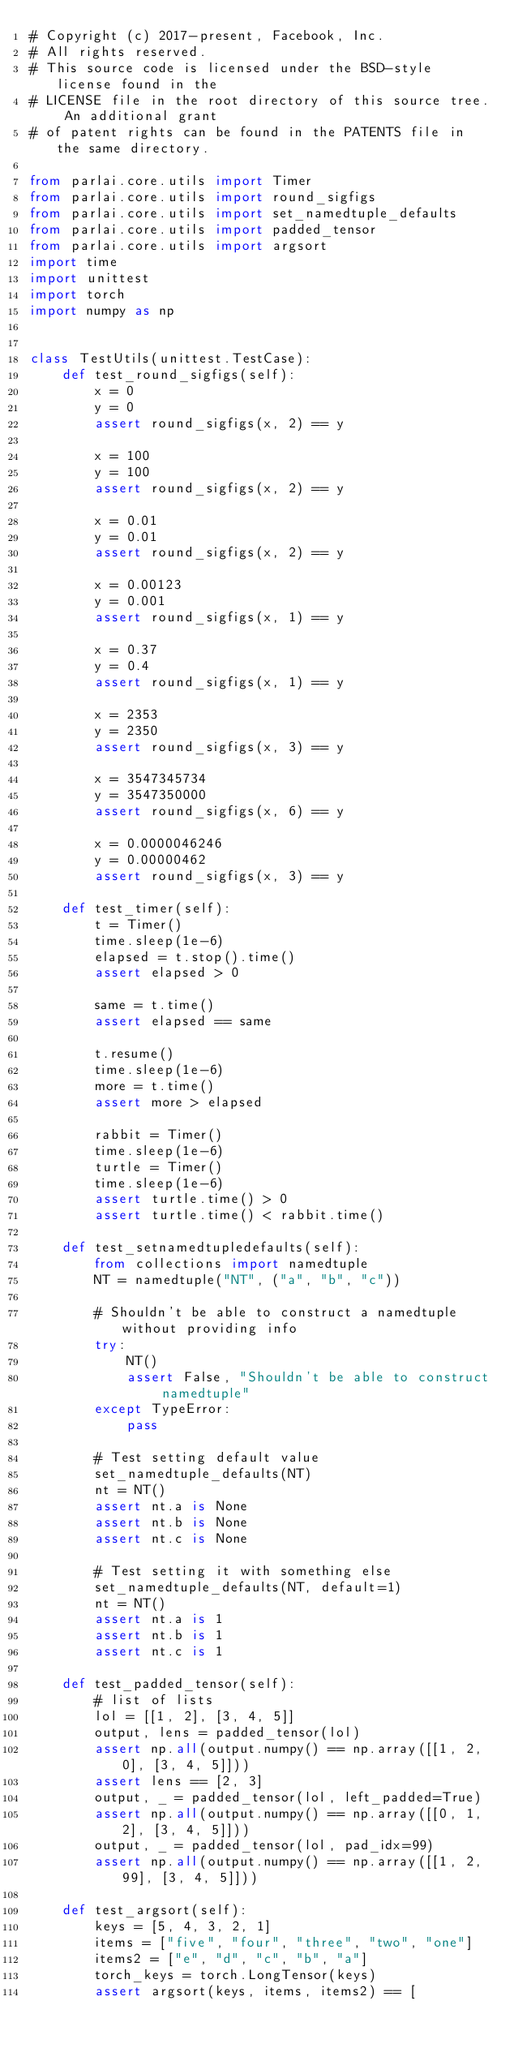Convert code to text. <code><loc_0><loc_0><loc_500><loc_500><_Python_># Copyright (c) 2017-present, Facebook, Inc.
# All rights reserved.
# This source code is licensed under the BSD-style license found in the
# LICENSE file in the root directory of this source tree. An additional grant
# of patent rights can be found in the PATENTS file in the same directory.

from parlai.core.utils import Timer
from parlai.core.utils import round_sigfigs
from parlai.core.utils import set_namedtuple_defaults
from parlai.core.utils import padded_tensor
from parlai.core.utils import argsort
import time
import unittest
import torch
import numpy as np


class TestUtils(unittest.TestCase):
    def test_round_sigfigs(self):
        x = 0
        y = 0
        assert round_sigfigs(x, 2) == y

        x = 100
        y = 100
        assert round_sigfigs(x, 2) == y

        x = 0.01
        y = 0.01
        assert round_sigfigs(x, 2) == y

        x = 0.00123
        y = 0.001
        assert round_sigfigs(x, 1) == y

        x = 0.37
        y = 0.4
        assert round_sigfigs(x, 1) == y

        x = 2353
        y = 2350
        assert round_sigfigs(x, 3) == y

        x = 3547345734
        y = 3547350000
        assert round_sigfigs(x, 6) == y

        x = 0.0000046246
        y = 0.00000462
        assert round_sigfigs(x, 3) == y

    def test_timer(self):
        t = Timer()
        time.sleep(1e-6)
        elapsed = t.stop().time()
        assert elapsed > 0

        same = t.time()
        assert elapsed == same

        t.resume()
        time.sleep(1e-6)
        more = t.time()
        assert more > elapsed

        rabbit = Timer()
        time.sleep(1e-6)
        turtle = Timer()
        time.sleep(1e-6)
        assert turtle.time() > 0
        assert turtle.time() < rabbit.time()

    def test_setnamedtupledefaults(self):
        from collections import namedtuple
        NT = namedtuple("NT", ("a", "b", "c"))

        # Shouldn't be able to construct a namedtuple without providing info
        try:
            NT()
            assert False, "Shouldn't be able to construct namedtuple"
        except TypeError:
            pass

        # Test setting default value
        set_namedtuple_defaults(NT)
        nt = NT()
        assert nt.a is None
        assert nt.b is None
        assert nt.c is None

        # Test setting it with something else
        set_namedtuple_defaults(NT, default=1)
        nt = NT()
        assert nt.a is 1
        assert nt.b is 1
        assert nt.c is 1

    def test_padded_tensor(self):
        # list of lists
        lol = [[1, 2], [3, 4, 5]]
        output, lens = padded_tensor(lol)
        assert np.all(output.numpy() == np.array([[1, 2, 0], [3, 4, 5]]))
        assert lens == [2, 3]
        output, _ = padded_tensor(lol, left_padded=True)
        assert np.all(output.numpy() == np.array([[0, 1, 2], [3, 4, 5]]))
        output, _ = padded_tensor(lol, pad_idx=99)
        assert np.all(output.numpy() == np.array([[1, 2, 99], [3, 4, 5]]))

    def test_argsort(self):
        keys = [5, 4, 3, 2, 1]
        items = ["five", "four", "three", "two", "one"]
        items2 = ["e", "d", "c", "b", "a"]
        torch_keys = torch.LongTensor(keys)
        assert argsort(keys, items, items2) == [</code> 